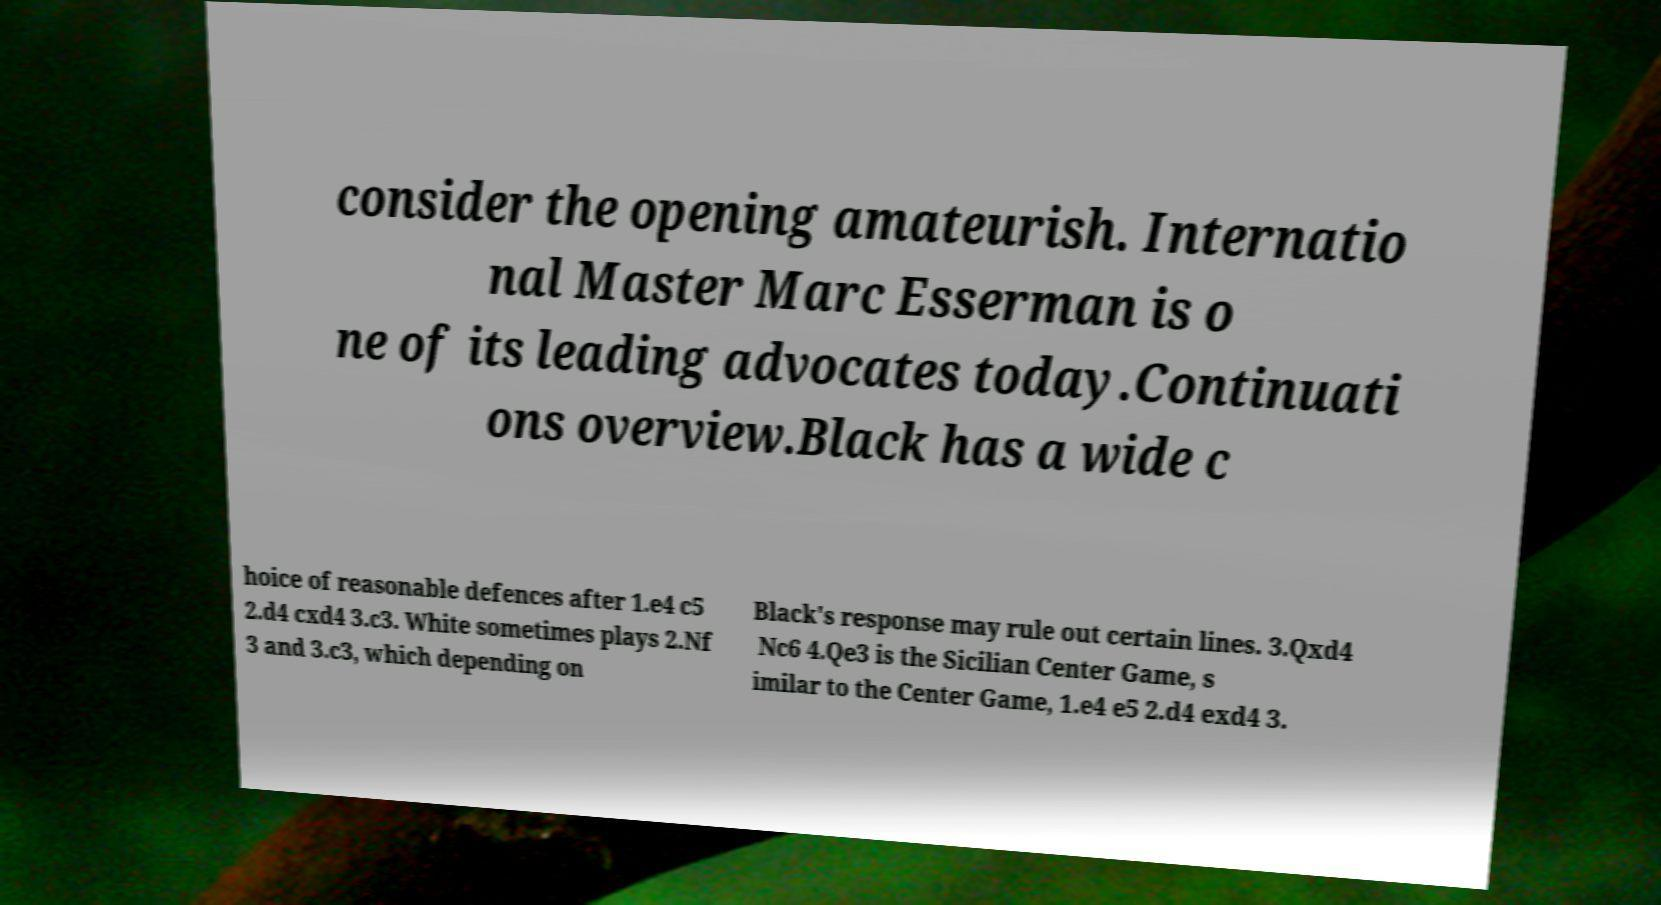Can you accurately transcribe the text from the provided image for me? consider the opening amateurish. Internatio nal Master Marc Esserman is o ne of its leading advocates today.Continuati ons overview.Black has a wide c hoice of reasonable defences after 1.e4 c5 2.d4 cxd4 3.c3. White sometimes plays 2.Nf 3 and 3.c3, which depending on Black's response may rule out certain lines. 3.Qxd4 Nc6 4.Qe3 is the Sicilian Center Game, s imilar to the Center Game, 1.e4 e5 2.d4 exd4 3. 